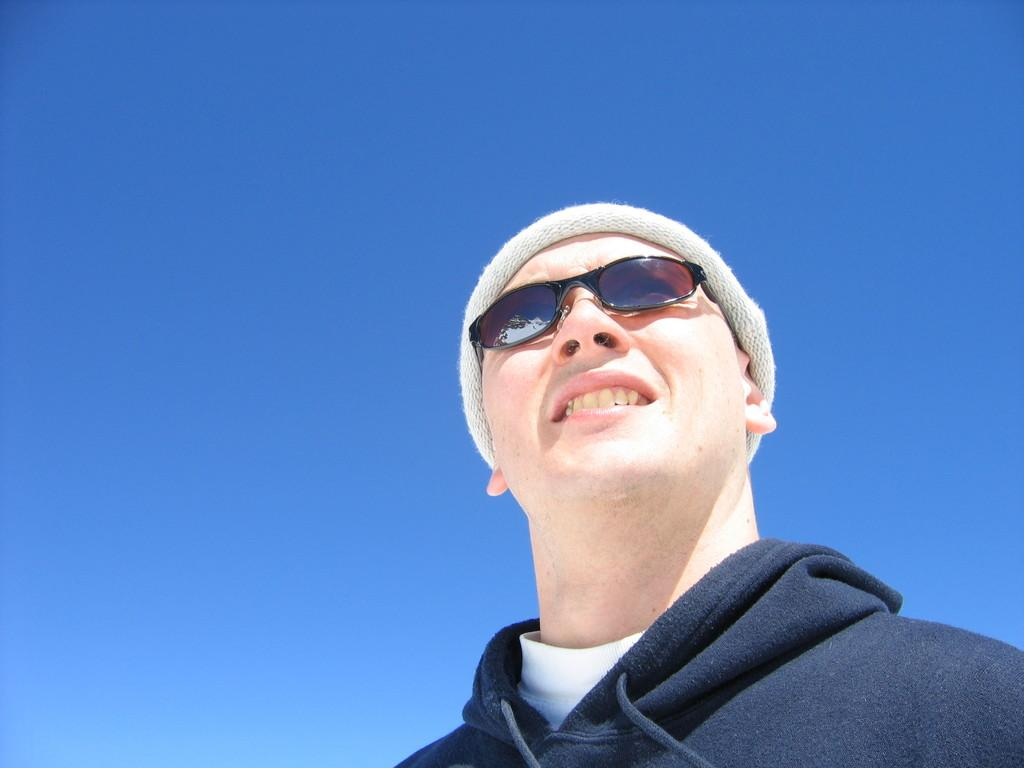Where is the man located in the image? The man is in the bottom right corner of the image. What is the man doing in the image? The man is standing in the image. What expression does the man have in the image? The man is smiling in the image. What can be seen behind the man in the image? There is sky visible behind the man in the image. What type of lawyer is sitting next to the man in the image? There is no sofa or lawyer present in the image; the man is standing in the bottom right corner. 